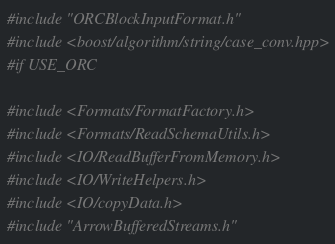<code> <loc_0><loc_0><loc_500><loc_500><_C++_>#include "ORCBlockInputFormat.h"
#include <boost/algorithm/string/case_conv.hpp>
#if USE_ORC

#include <Formats/FormatFactory.h>
#include <Formats/ReadSchemaUtils.h>
#include <IO/ReadBufferFromMemory.h>
#include <IO/WriteHelpers.h>
#include <IO/copyData.h>
#include "ArrowBufferedStreams.h"</code> 